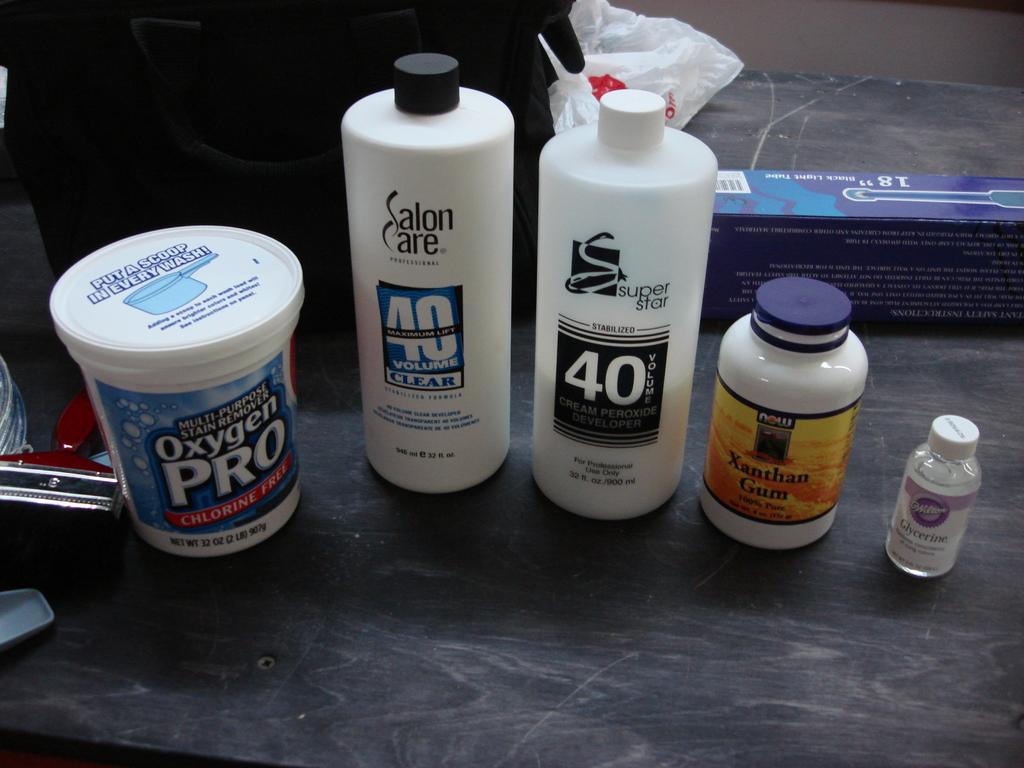How much oxygen pro should be added to a load of laundry?
Your answer should be very brief. A scoop. What are the vitamins?
Your answer should be very brief. Xanthan gum. 